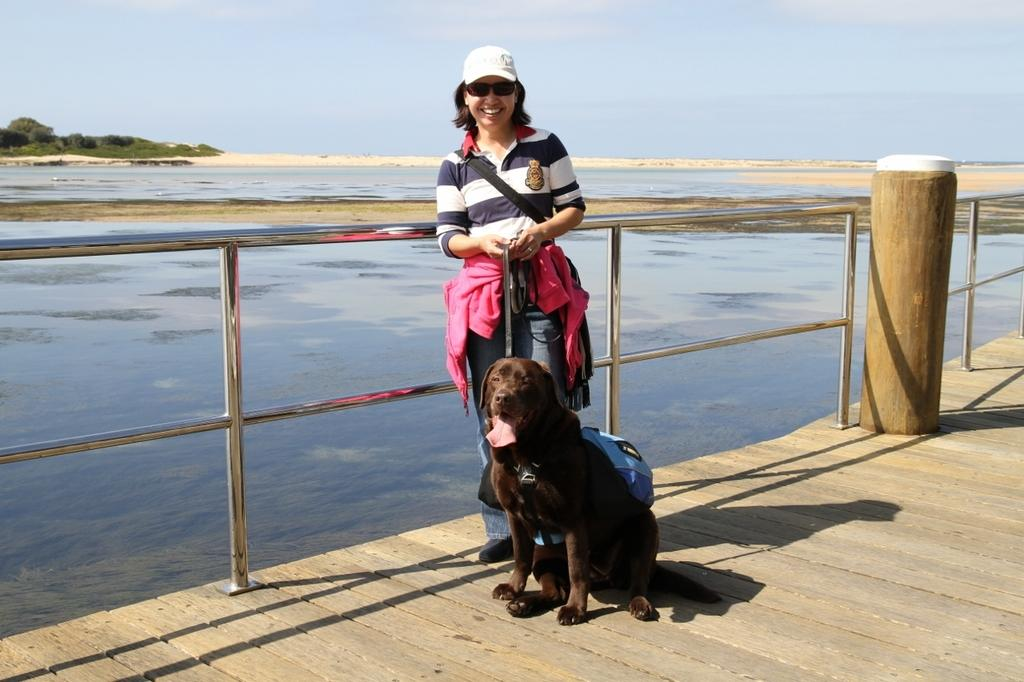Who is the main subject in the image? There is a woman in the image. What is the woman doing in the image? The woman is posing for a camera. What animal is present in the image? There is a dog in front of the woman. What can be seen in the distance in the image? There is a water body in the background of the image. What type of clock is visible on the desk in the image? There is no clock or desk present in the image. 